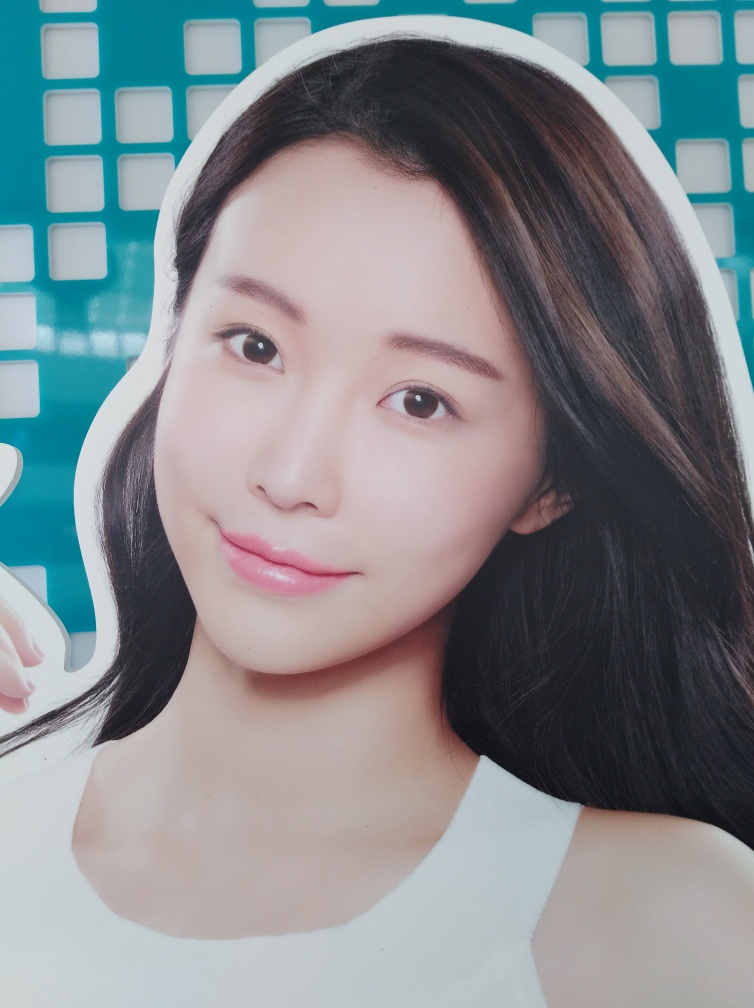Can you tell me more about the style of this advertisement? The style of the advertisement seems modern and clean, employing a large, high-quality image of a model with a fresh and appealing look to attract attention to the advertised product or service's potential benefits. 